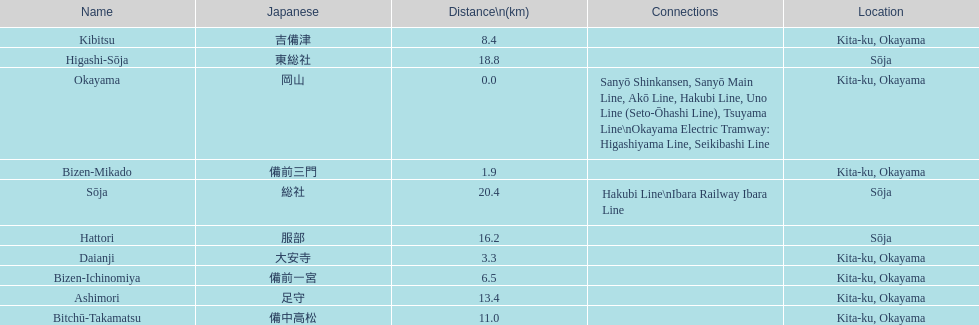Which has a distance less than 3.0 kilometers? Bizen-Mikado. 